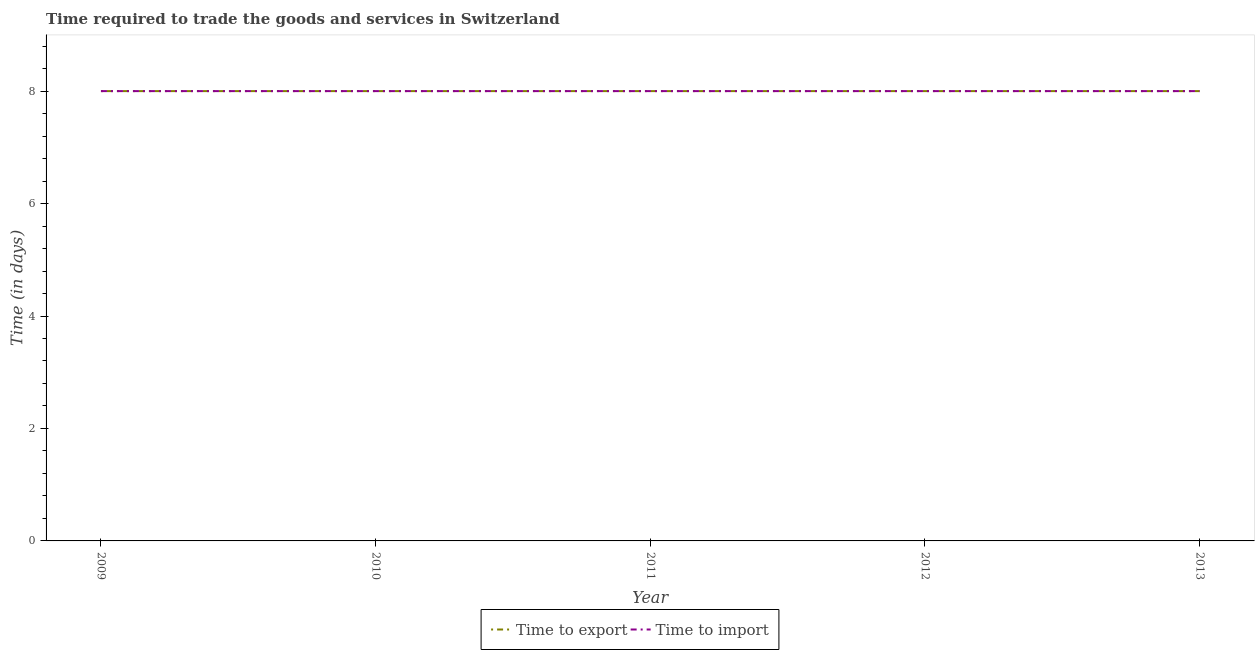How many different coloured lines are there?
Your response must be concise. 2. What is the time to export in 2009?
Keep it short and to the point. 8. Across all years, what is the maximum time to export?
Offer a very short reply. 8. Across all years, what is the minimum time to export?
Provide a short and direct response. 8. In which year was the time to export maximum?
Give a very brief answer. 2009. What is the total time to import in the graph?
Your response must be concise. 40. Is the difference between the time to export in 2011 and 2012 greater than the difference between the time to import in 2011 and 2012?
Provide a short and direct response. No. In how many years, is the time to import greater than the average time to import taken over all years?
Your response must be concise. 0. Is the sum of the time to import in 2010 and 2012 greater than the maximum time to export across all years?
Keep it short and to the point. Yes. Does the time to export monotonically increase over the years?
Offer a very short reply. No. Is the time to import strictly greater than the time to export over the years?
Your answer should be very brief. No. Is the time to import strictly less than the time to export over the years?
Offer a very short reply. No. How many lines are there?
Provide a succinct answer. 2. What is the difference between two consecutive major ticks on the Y-axis?
Give a very brief answer. 2. Are the values on the major ticks of Y-axis written in scientific E-notation?
Make the answer very short. No. How many legend labels are there?
Provide a succinct answer. 2. How are the legend labels stacked?
Offer a very short reply. Horizontal. What is the title of the graph?
Make the answer very short. Time required to trade the goods and services in Switzerland. What is the label or title of the Y-axis?
Ensure brevity in your answer.  Time (in days). What is the Time (in days) of Time to export in 2009?
Give a very brief answer. 8. What is the Time (in days) of Time to import in 2009?
Offer a terse response. 8. What is the Time (in days) of Time to import in 2011?
Ensure brevity in your answer.  8. What is the Time (in days) of Time to import in 2012?
Make the answer very short. 8. What is the Time (in days) in Time to import in 2013?
Ensure brevity in your answer.  8. Across all years, what is the minimum Time (in days) in Time to export?
Provide a succinct answer. 8. Across all years, what is the minimum Time (in days) of Time to import?
Ensure brevity in your answer.  8. What is the difference between the Time (in days) in Time to export in 2009 and that in 2011?
Your answer should be very brief. 0. What is the difference between the Time (in days) in Time to import in 2009 and that in 2011?
Provide a short and direct response. 0. What is the difference between the Time (in days) of Time to export in 2009 and that in 2013?
Give a very brief answer. 0. What is the difference between the Time (in days) in Time to import in 2009 and that in 2013?
Provide a short and direct response. 0. What is the difference between the Time (in days) in Time to export in 2010 and that in 2011?
Ensure brevity in your answer.  0. What is the difference between the Time (in days) in Time to export in 2010 and that in 2012?
Provide a succinct answer. 0. What is the difference between the Time (in days) in Time to import in 2010 and that in 2012?
Give a very brief answer. 0. What is the difference between the Time (in days) in Time to export in 2010 and that in 2013?
Provide a short and direct response. 0. What is the difference between the Time (in days) in Time to export in 2011 and that in 2012?
Ensure brevity in your answer.  0. What is the difference between the Time (in days) in Time to import in 2011 and that in 2013?
Provide a succinct answer. 0. What is the difference between the Time (in days) of Time to import in 2012 and that in 2013?
Offer a very short reply. 0. What is the difference between the Time (in days) in Time to export in 2009 and the Time (in days) in Time to import in 2011?
Provide a short and direct response. 0. What is the difference between the Time (in days) of Time to export in 2009 and the Time (in days) of Time to import in 2012?
Provide a succinct answer. 0. What is the difference between the Time (in days) of Time to export in 2010 and the Time (in days) of Time to import in 2012?
Ensure brevity in your answer.  0. What is the difference between the Time (in days) in Time to export in 2010 and the Time (in days) in Time to import in 2013?
Your response must be concise. 0. What is the difference between the Time (in days) in Time to export in 2011 and the Time (in days) in Time to import in 2012?
Make the answer very short. 0. What is the difference between the Time (in days) in Time to export in 2011 and the Time (in days) in Time to import in 2013?
Provide a succinct answer. 0. In the year 2011, what is the difference between the Time (in days) of Time to export and Time (in days) of Time to import?
Ensure brevity in your answer.  0. In the year 2012, what is the difference between the Time (in days) in Time to export and Time (in days) in Time to import?
Make the answer very short. 0. What is the ratio of the Time (in days) in Time to export in 2009 to that in 2010?
Your answer should be compact. 1. What is the ratio of the Time (in days) of Time to import in 2009 to that in 2010?
Provide a short and direct response. 1. What is the ratio of the Time (in days) in Time to import in 2009 to that in 2011?
Give a very brief answer. 1. What is the ratio of the Time (in days) in Time to export in 2009 to that in 2012?
Give a very brief answer. 1. What is the ratio of the Time (in days) in Time to import in 2009 to that in 2012?
Offer a very short reply. 1. What is the ratio of the Time (in days) in Time to import in 2010 to that in 2011?
Provide a short and direct response. 1. What is the ratio of the Time (in days) in Time to import in 2010 to that in 2012?
Your answer should be compact. 1. What is the ratio of the Time (in days) of Time to export in 2010 to that in 2013?
Provide a succinct answer. 1. What is the ratio of the Time (in days) in Time to import in 2010 to that in 2013?
Give a very brief answer. 1. What is the ratio of the Time (in days) in Time to export in 2011 to that in 2012?
Provide a succinct answer. 1. What is the ratio of the Time (in days) of Time to import in 2011 to that in 2012?
Offer a very short reply. 1. What is the ratio of the Time (in days) in Time to import in 2011 to that in 2013?
Provide a succinct answer. 1. What is the ratio of the Time (in days) of Time to export in 2012 to that in 2013?
Offer a very short reply. 1. 